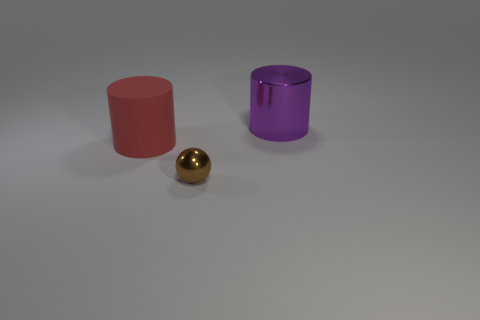Are there any other things that have the same size as the ball?
Your answer should be compact. No. The red object that is the same shape as the purple metallic thing is what size?
Your answer should be compact. Large. Is there a purple metallic cylinder that is behind the large cylinder that is in front of the big purple metal object?
Your answer should be very brief. Yes. What number of other things are the same shape as the small brown shiny object?
Provide a succinct answer. 0. Are there more brown metal balls in front of the purple metallic cylinder than shiny cylinders behind the brown sphere?
Provide a short and direct response. No. There is a cylinder to the right of the red rubber cylinder; is it the same size as the cylinder in front of the large purple shiny object?
Keep it short and to the point. Yes. There is a big rubber object; what shape is it?
Offer a very short reply. Cylinder. There is a big cylinder that is the same material as the brown thing; what is its color?
Make the answer very short. Purple. Is the large purple cylinder made of the same material as the large object that is left of the tiny shiny sphere?
Your answer should be compact. No. What is the color of the small sphere?
Offer a very short reply. Brown. 